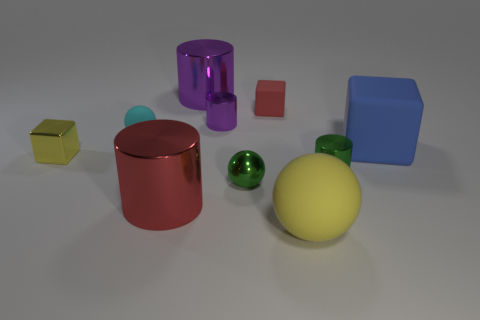Subtract all gray blocks. How many purple cylinders are left? 2 Subtract all tiny cubes. How many cubes are left? 1 Subtract 1 cubes. How many cubes are left? 2 Subtract all red cylinders. How many cylinders are left? 3 Subtract all balls. How many objects are left? 7 Subtract all brown cylinders. Subtract all purple blocks. How many cylinders are left? 4 Subtract all large cyan shiny balls. Subtract all large purple metallic objects. How many objects are left? 9 Add 3 large yellow rubber objects. How many large yellow rubber objects are left? 4 Add 8 purple metallic cylinders. How many purple metallic cylinders exist? 10 Subtract 0 brown cylinders. How many objects are left? 10 